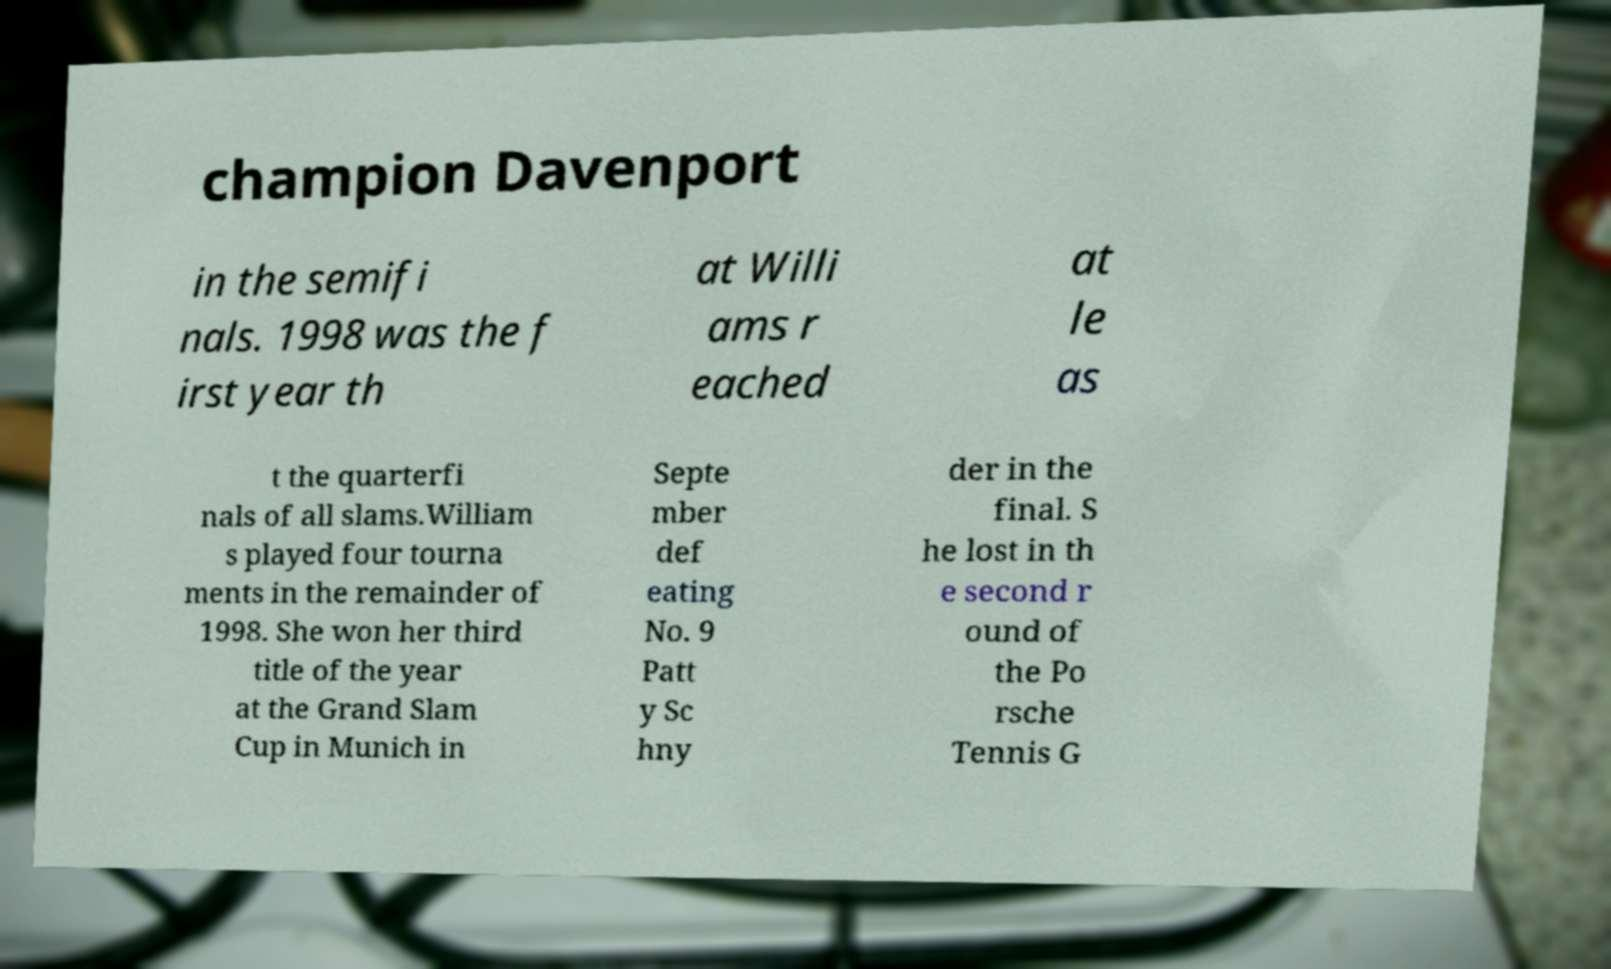Can you accurately transcribe the text from the provided image for me? champion Davenport in the semifi nals. 1998 was the f irst year th at Willi ams r eached at le as t the quarterfi nals of all slams.William s played four tourna ments in the remainder of 1998. She won her third title of the year at the Grand Slam Cup in Munich in Septe mber def eating No. 9 Patt y Sc hny der in the final. S he lost in th e second r ound of the Po rsche Tennis G 